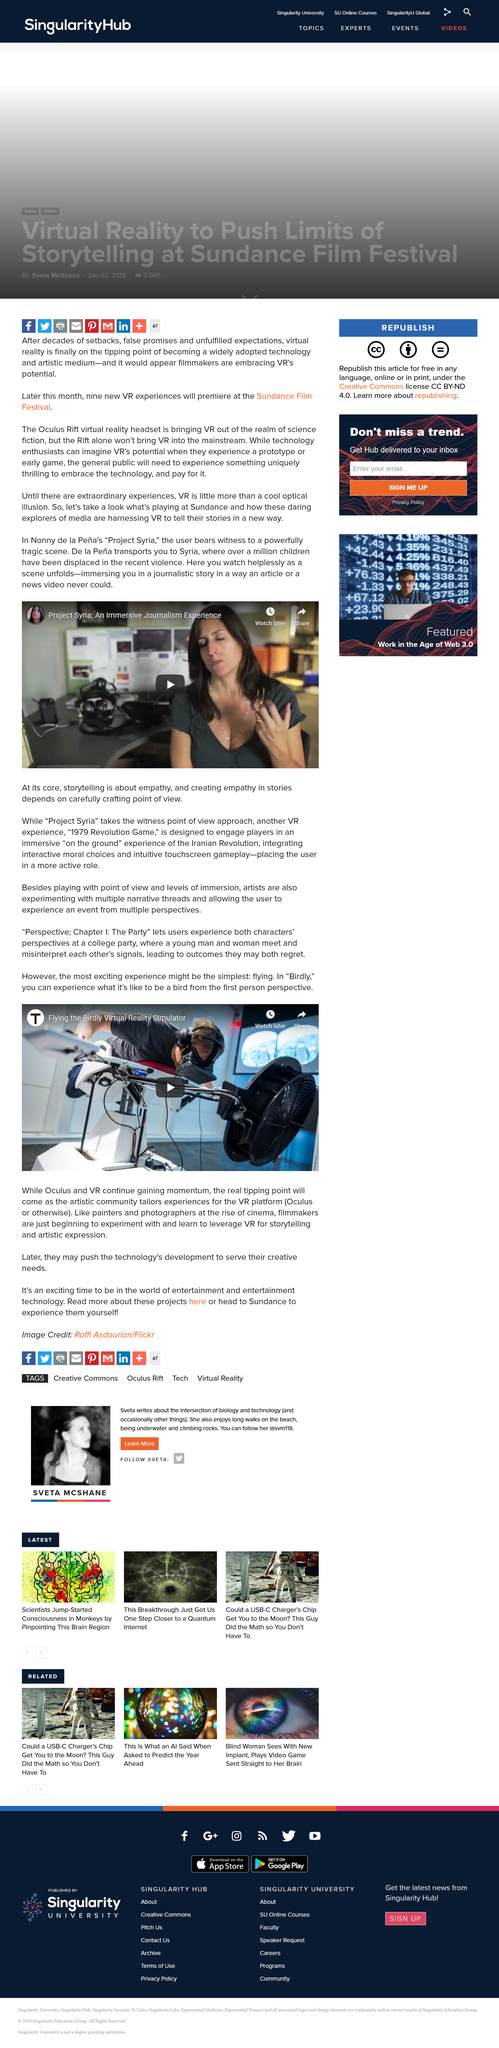Identify some key points in this picture. The author suggests that VR will become mainstream when the general public experiences something uniquely thrilling. According to recent violence, over a million children have been displaced. 